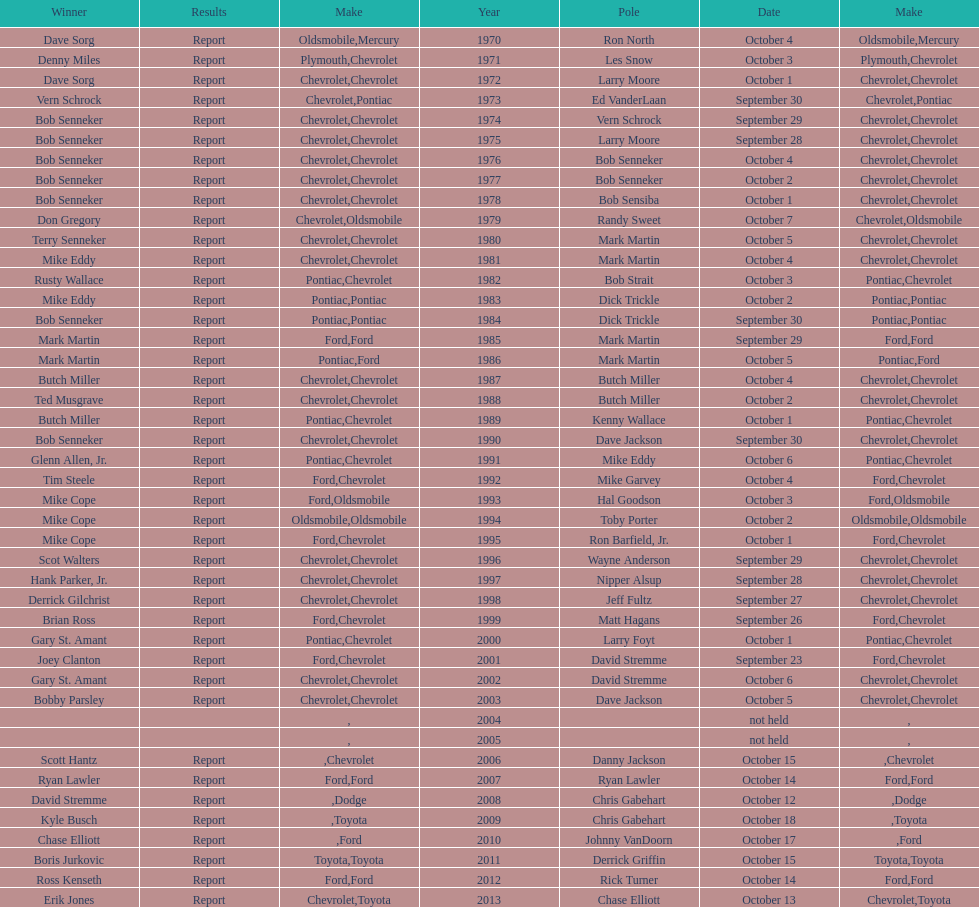Who on the list has the highest number of consecutive wins? Bob Senneker. 